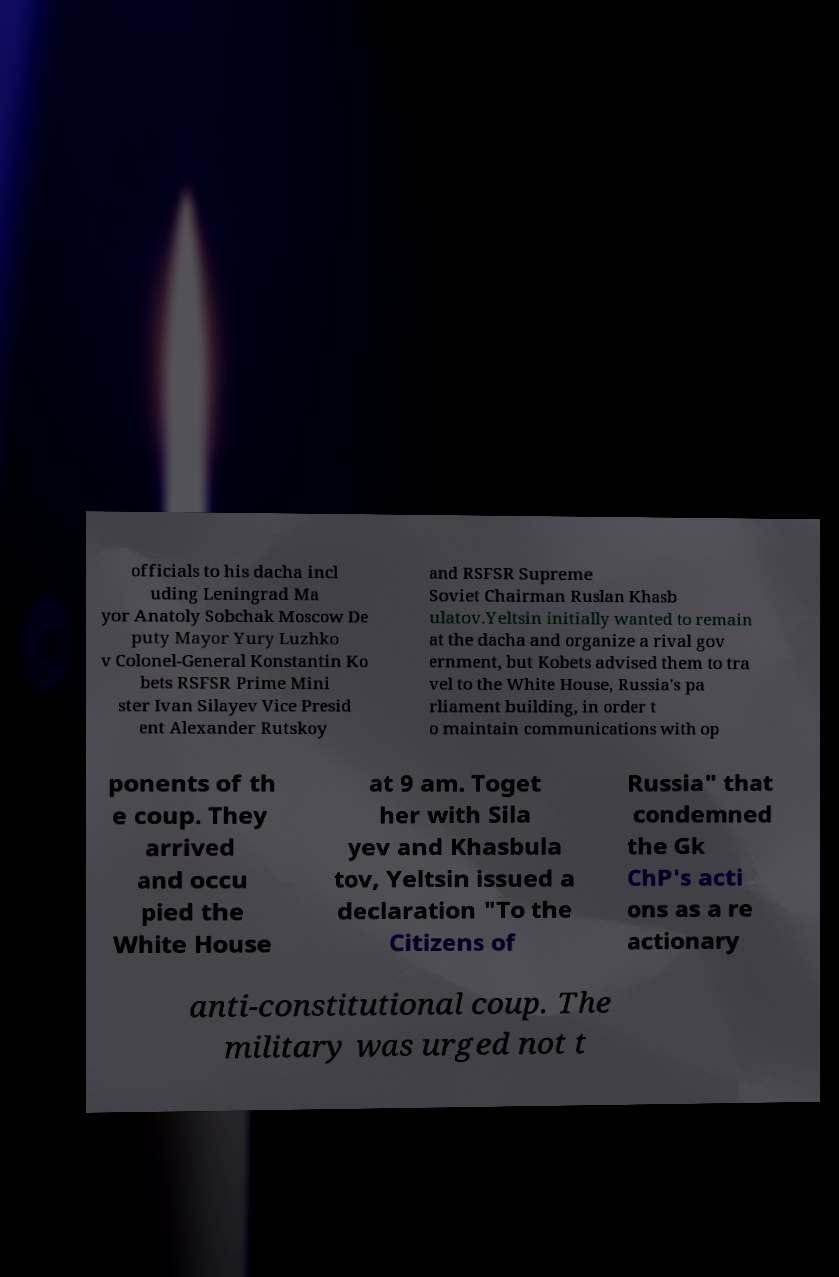There's text embedded in this image that I need extracted. Can you transcribe it verbatim? officials to his dacha incl uding Leningrad Ma yor Anatoly Sobchak Moscow De puty Mayor Yury Luzhko v Colonel-General Konstantin Ko bets RSFSR Prime Mini ster Ivan Silayev Vice Presid ent Alexander Rutskoy and RSFSR Supreme Soviet Chairman Ruslan Khasb ulatov.Yeltsin initially wanted to remain at the dacha and organize a rival gov ernment, but Kobets advised them to tra vel to the White House, Russia's pa rliament building, in order t o maintain communications with op ponents of th e coup. They arrived and occu pied the White House at 9 am. Toget her with Sila yev and Khasbula tov, Yeltsin issued a declaration "To the Citizens of Russia" that condemned the Gk ChP's acti ons as a re actionary anti-constitutional coup. The military was urged not t 